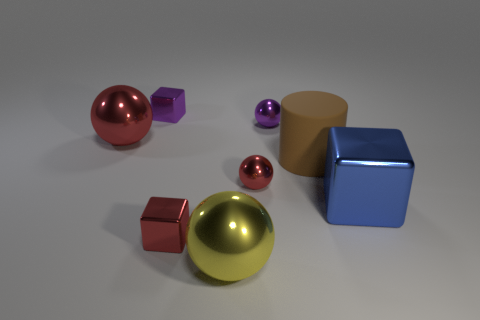What number of large things are both on the left side of the brown thing and on the right side of the large yellow ball? There are no large objects that fit the criteria of being both on the left side of the brown object and on the right side of the large yellow ball at the same time. 